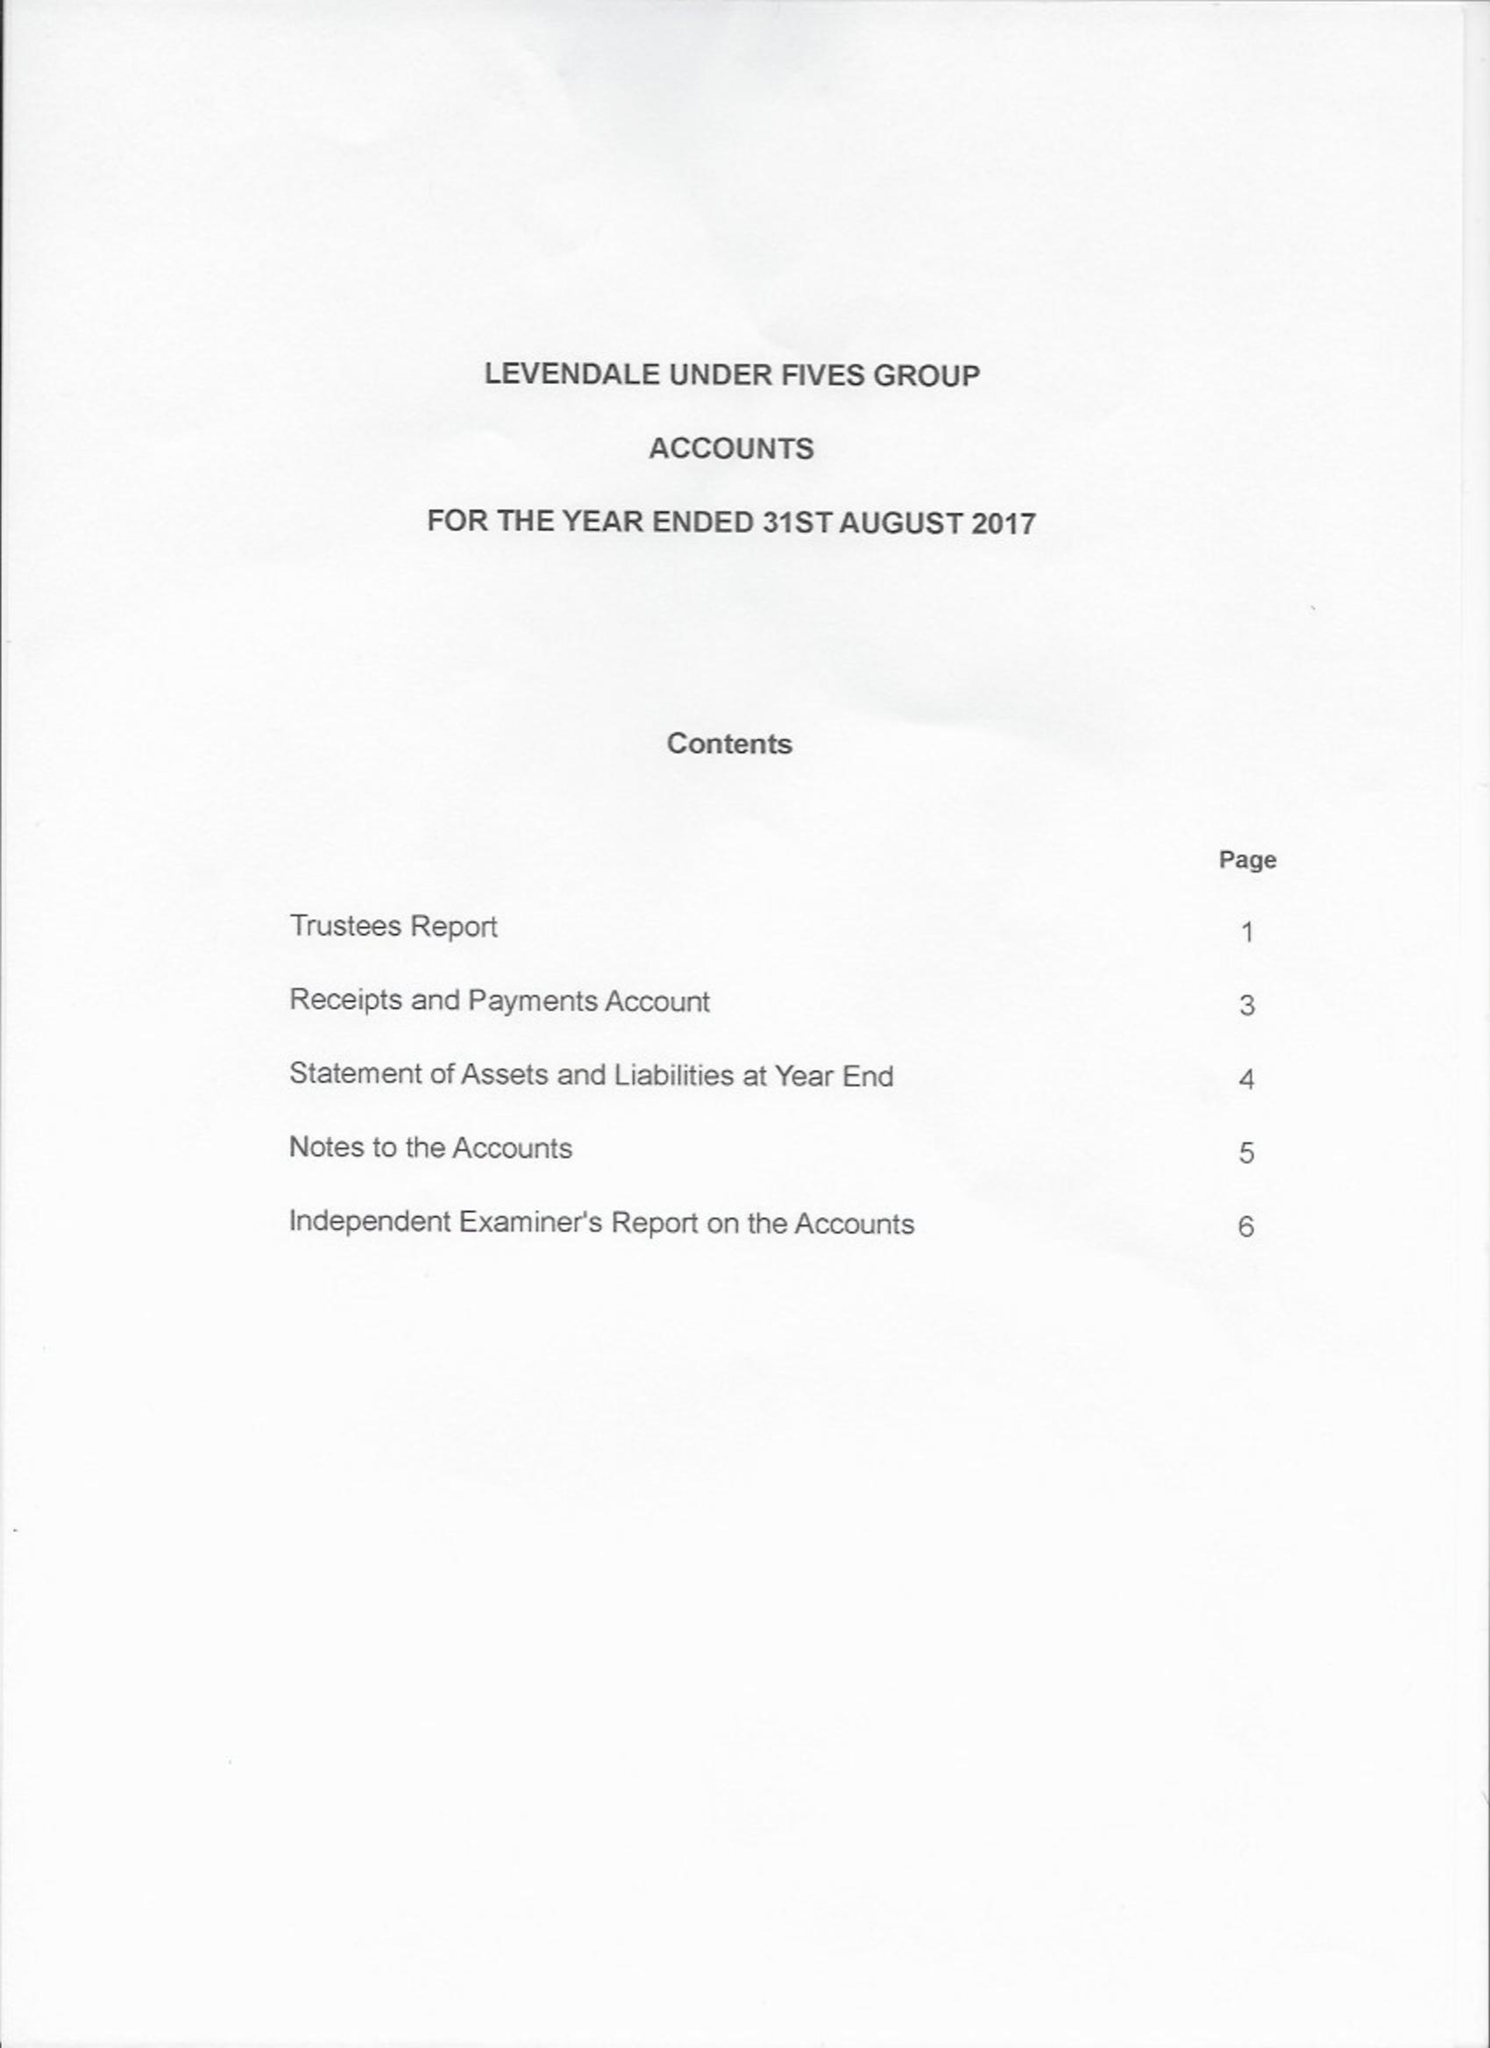What is the value for the income_annually_in_british_pounds?
Answer the question using a single word or phrase. 32353.00 